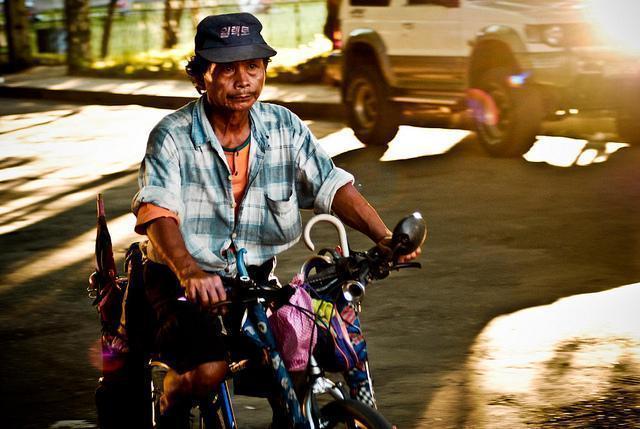Why do they have so many umbrellas?
Pick the correct solution from the four options below to address the question.
Options: Cleaning them, found them, selling them, stole them. Selling them. 